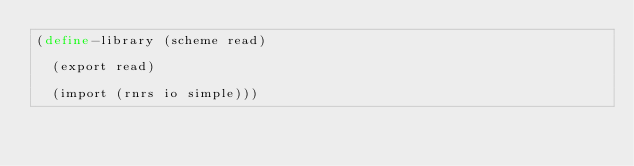Convert code to text. <code><loc_0><loc_0><loc_500><loc_500><_Scheme_>(define-library (scheme read)

  (export read)

  (import (rnrs io simple)))
</code> 